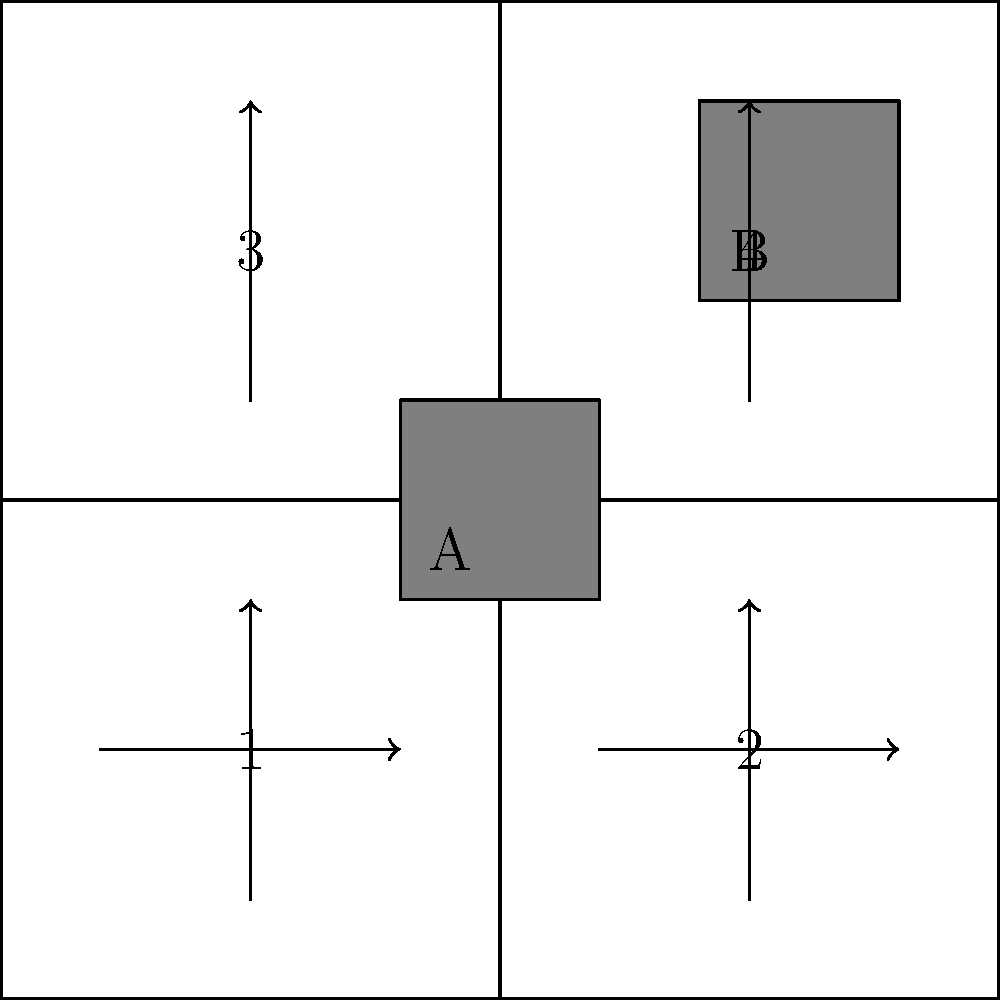Based on the traffic flow diagram showing the impact of high-rise expansion (buildings A and B) on city streets, which intersection is likely to experience the most significant increase in traffic congestion? To determine which intersection will experience the most significant increase in traffic congestion due to the high-rise expansion, we need to analyze the traffic flow patterns and the location of the new buildings:

1. The diagram shows two new high-rise buildings (A and B) added to the city grid.
2. Traffic flow is indicated by arrows on the streets.
3. There are four main intersections, labeled 1, 2, 3, and 4.

Let's analyze each intersection:

1. Intersection 1 (bottom-left): This intersection is close to building A and has incoming traffic from two directions.
2. Intersection 2 (bottom-right): This intersection has incoming traffic from two directions but is not directly adjacent to either new building.
3. Intersection 3 (top-left): This intersection has incoming traffic from two directions but is not directly adjacent to either new building.
4. Intersection 4 (top-right): This intersection is close to building B and has incoming traffic from two directions.

The intersections closest to the new high-rise buildings (1 and 4) are likely to experience the most significant increase in traffic due to:
a) Increased residential or commercial activity in the new buildings.
b) More people entering and exiting the buildings during peak hours.
c) Potential bottlenecks created by increased pedestrian traffic around the buildings.

Of these two intersections, intersection 4 is likely to experience the most significant increase in traffic congestion because:
1. It is adjacent to building B, which appears larger than building A.
2. It is located in the upper-right quadrant of the city grid, which often experiences more development and activity in urban settings.
3. The traffic flow arrows indicate that vehicles approach this intersection from multiple directions, potentially creating more complex traffic patterns.
Answer: Intersection 4 